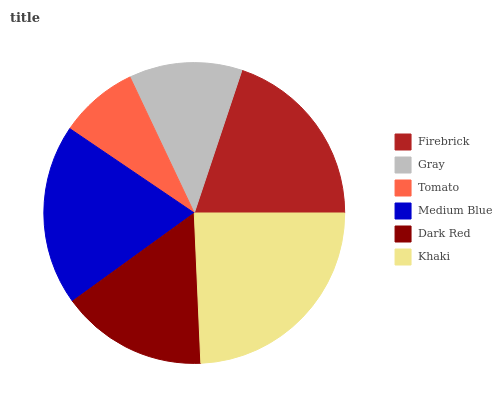Is Tomato the minimum?
Answer yes or no. Yes. Is Khaki the maximum?
Answer yes or no. Yes. Is Gray the minimum?
Answer yes or no. No. Is Gray the maximum?
Answer yes or no. No. Is Firebrick greater than Gray?
Answer yes or no. Yes. Is Gray less than Firebrick?
Answer yes or no. Yes. Is Gray greater than Firebrick?
Answer yes or no. No. Is Firebrick less than Gray?
Answer yes or no. No. Is Medium Blue the high median?
Answer yes or no. Yes. Is Dark Red the low median?
Answer yes or no. Yes. Is Khaki the high median?
Answer yes or no. No. Is Firebrick the low median?
Answer yes or no. No. 